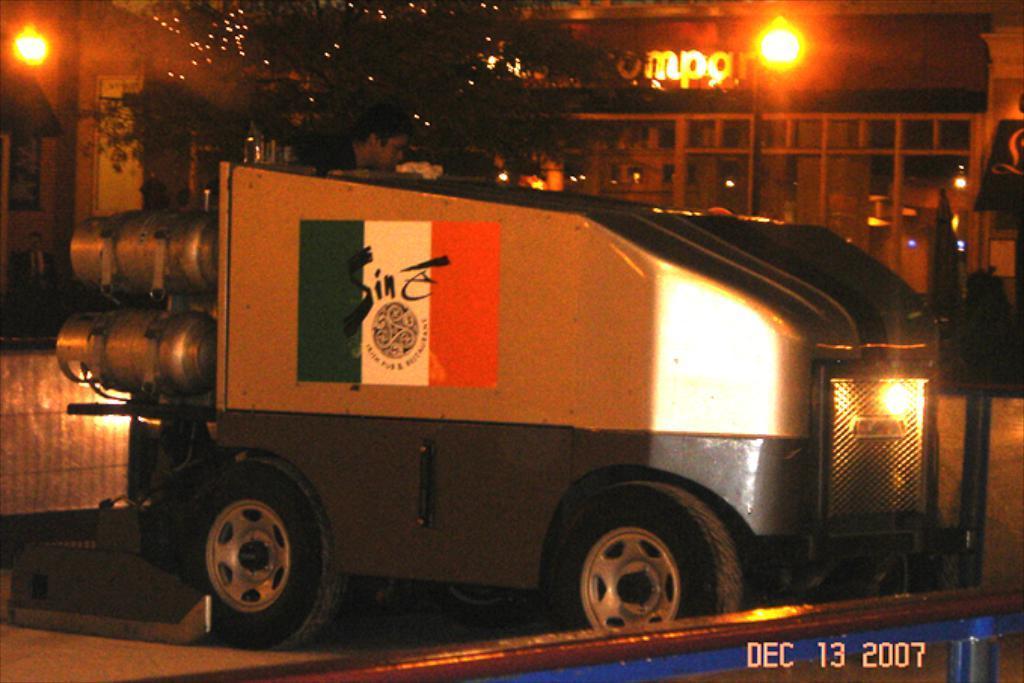Can you describe this image briefly? In this image I can see a vehicle in the front and on it I can see a man. In the background I can see a tree, two lights, a building, few boards and on it I can see something is written. On the bottom right side of the image, I can see a watermark and I can also see depiction of a flag on the vehicle. 